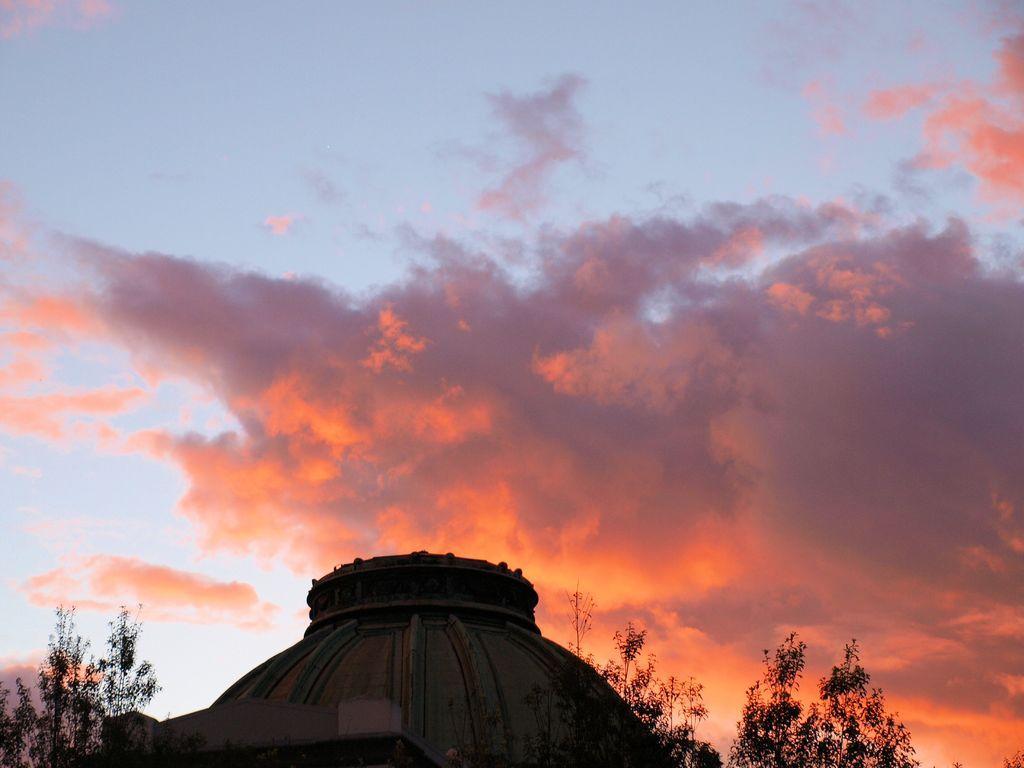How would you summarize this image in a sentence or two? In this image we can see top of a building. Near to that there are trees. In the background there is sky with clouds. 